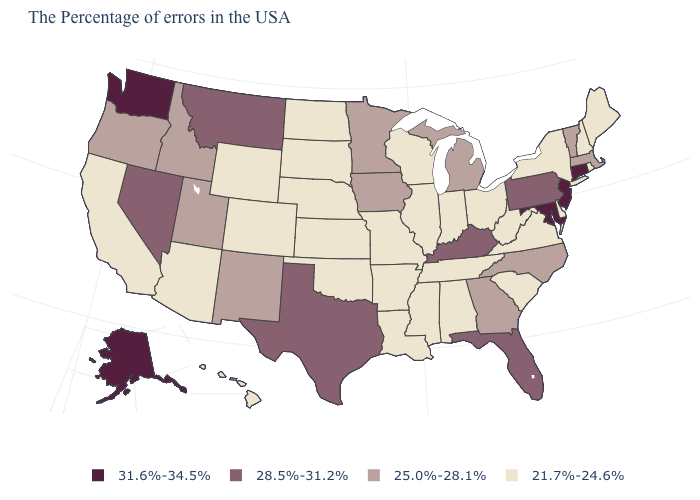Name the states that have a value in the range 31.6%-34.5%?
Keep it brief. Connecticut, New Jersey, Maryland, Washington, Alaska. What is the value of Delaware?
Short answer required. 21.7%-24.6%. What is the value of Hawaii?
Give a very brief answer. 21.7%-24.6%. What is the value of Colorado?
Give a very brief answer. 21.7%-24.6%. Does Oregon have the lowest value in the West?
Quick response, please. No. What is the lowest value in the West?
Keep it brief. 21.7%-24.6%. Among the states that border Alabama , does Mississippi have the highest value?
Answer briefly. No. Name the states that have a value in the range 31.6%-34.5%?
Be succinct. Connecticut, New Jersey, Maryland, Washington, Alaska. Among the states that border Maine , which have the lowest value?
Keep it brief. New Hampshire. Does Michigan have the same value as Oregon?
Be succinct. Yes. What is the value of West Virginia?
Keep it brief. 21.7%-24.6%. Among the states that border Idaho , which have the highest value?
Be succinct. Washington. What is the highest value in the USA?
Give a very brief answer. 31.6%-34.5%. Does the map have missing data?
Write a very short answer. No. What is the value of Colorado?
Keep it brief. 21.7%-24.6%. 